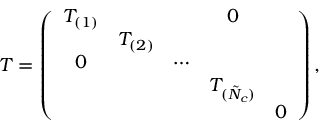<formula> <loc_0><loc_0><loc_500><loc_500>T = \left ( \begin{array} { c c c c c } { { T _ { ( 1 ) } } } & { 0 } & { { T _ { ( 2 ) } } } \\ { 0 } & { \cdots } & { { T _ { ( \tilde { N } _ { c } ) } } } & { 0 } \end{array} \right ) ,</formula> 